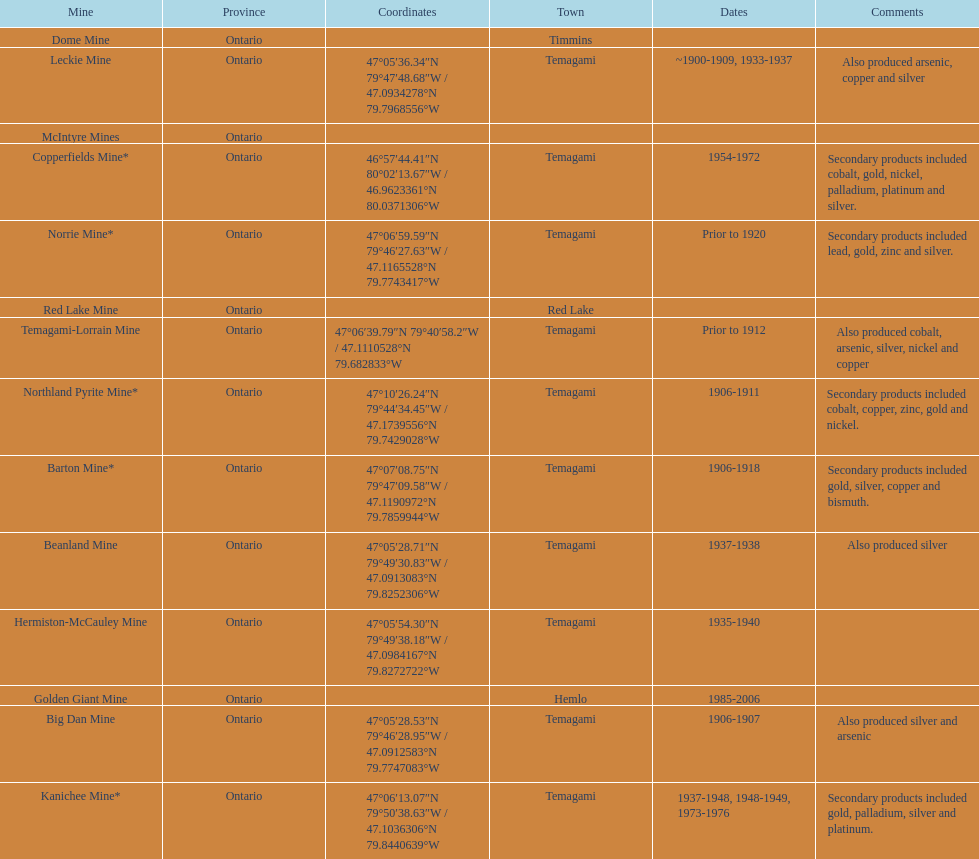What province is the town of temagami? Ontario. 